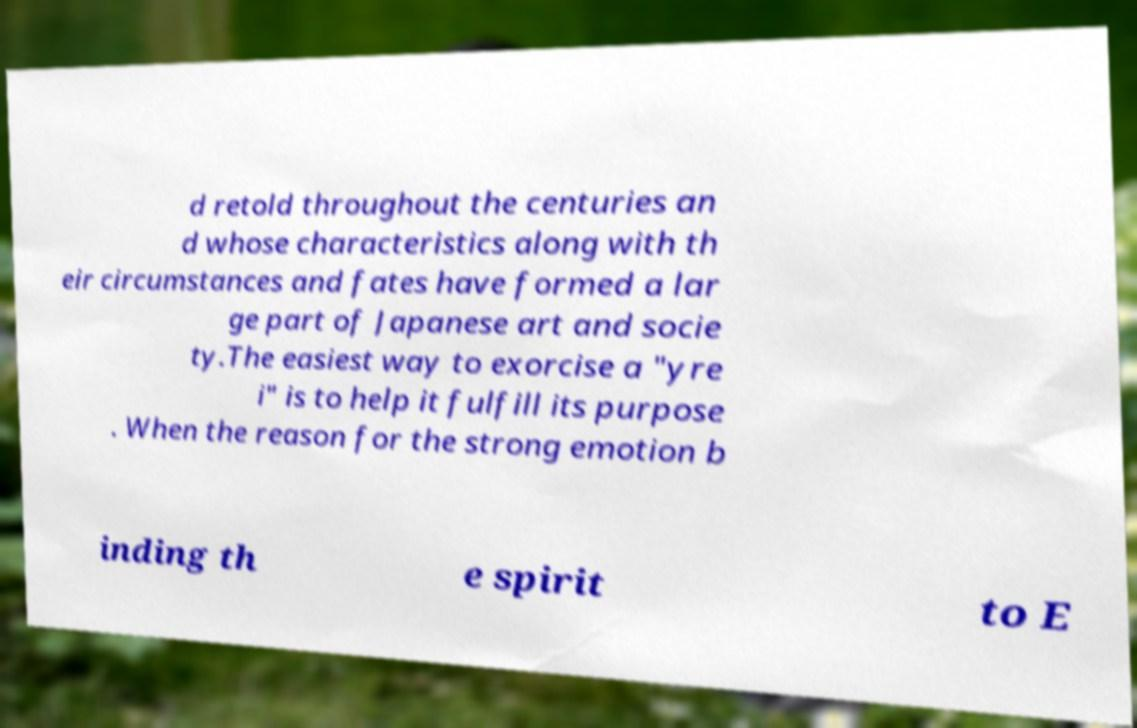Please identify and transcribe the text found in this image. d retold throughout the centuries an d whose characteristics along with th eir circumstances and fates have formed a lar ge part of Japanese art and socie ty.The easiest way to exorcise a "yre i" is to help it fulfill its purpose . When the reason for the strong emotion b inding th e spirit to E 